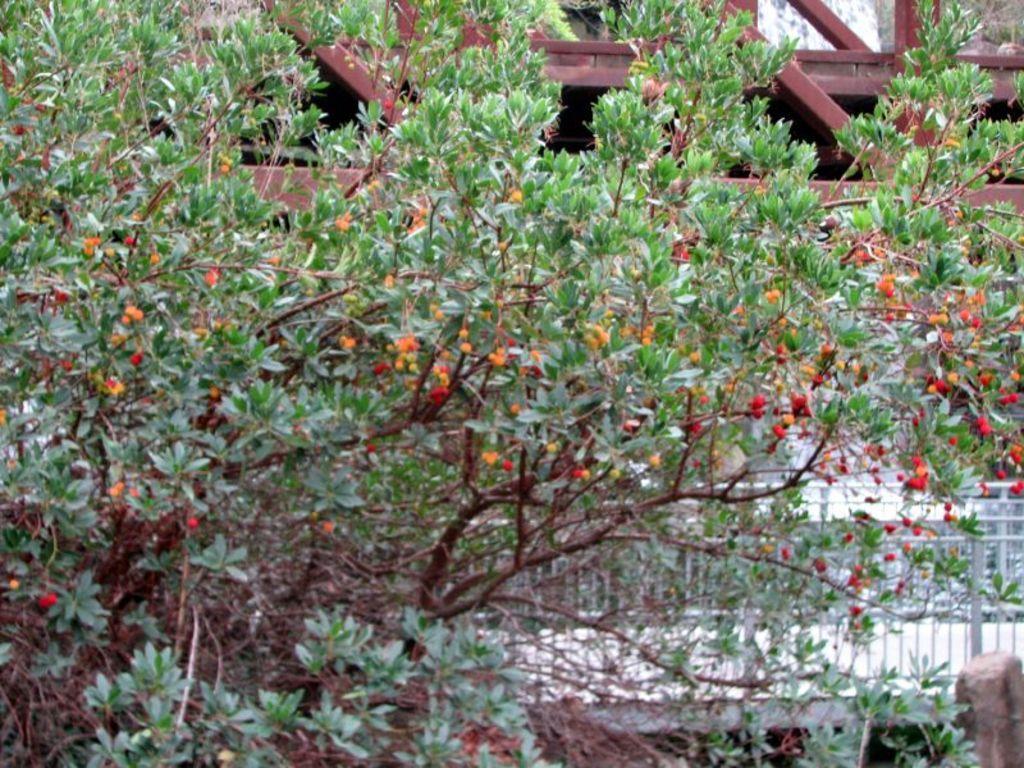Please provide a concise description of this image. In the foreground of the image we can see a tree with leaves and fruits. And we can see wooden structure at the top. One railing is there in the background of the image. 